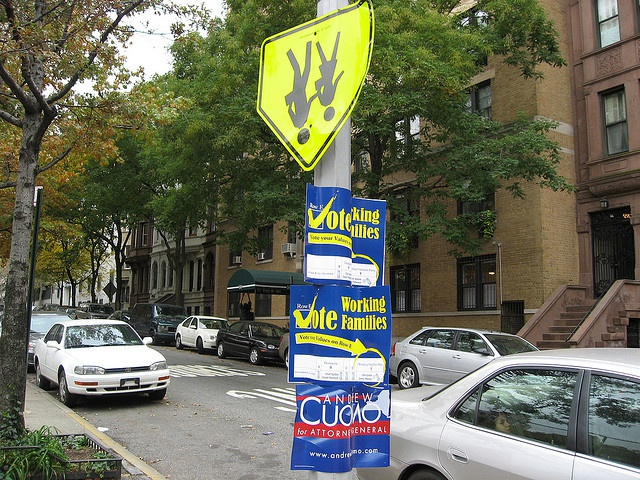Describe the objects in this image and their specific colors. I can see car in black, lightgray, darkgray, and gray tones, car in black, white, darkgray, and gray tones, car in black, darkgray, lightgray, and gray tones, car in black, gray, darkgreen, and darkgray tones, and car in black, gray, white, and darkgray tones in this image. 